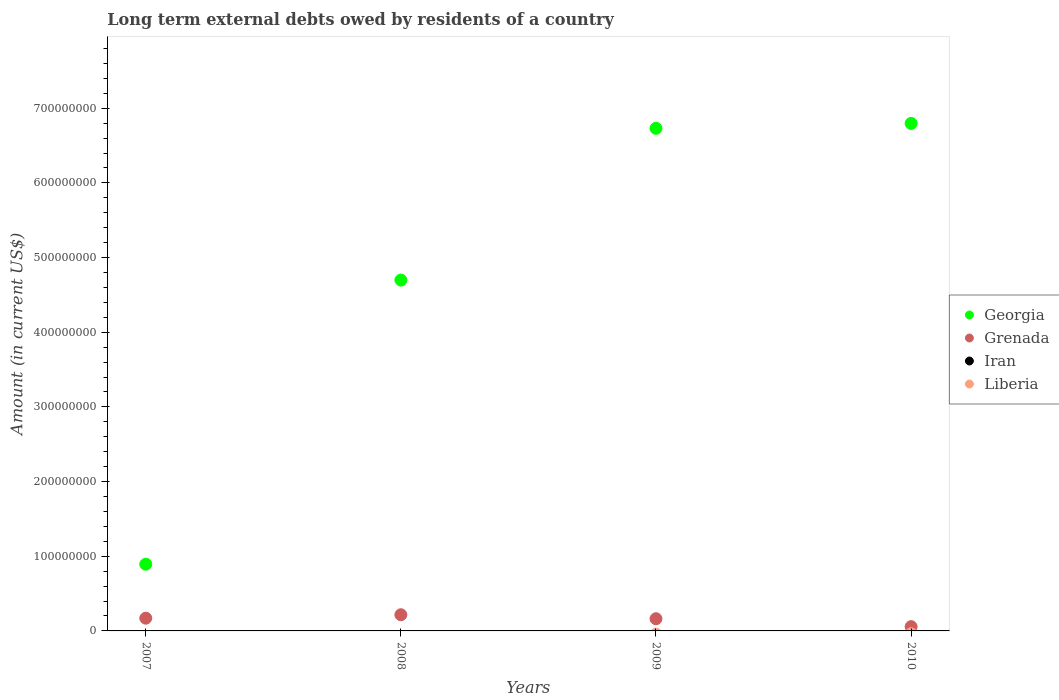How many different coloured dotlines are there?
Provide a succinct answer. 2. Is the number of dotlines equal to the number of legend labels?
Provide a succinct answer. No. What is the amount of long-term external debts owed by residents in Georgia in 2009?
Provide a short and direct response. 6.73e+08. Across all years, what is the maximum amount of long-term external debts owed by residents in Georgia?
Give a very brief answer. 6.80e+08. Across all years, what is the minimum amount of long-term external debts owed by residents in Liberia?
Offer a very short reply. 0. What is the total amount of long-term external debts owed by residents in Grenada in the graph?
Provide a short and direct response. 6.08e+07. What is the difference between the amount of long-term external debts owed by residents in Georgia in 2008 and that in 2009?
Offer a very short reply. -2.03e+08. What is the difference between the amount of long-term external debts owed by residents in Grenada in 2008 and the amount of long-term external debts owed by residents in Iran in 2009?
Your response must be concise. 2.17e+07. What is the average amount of long-term external debts owed by residents in Grenada per year?
Provide a short and direct response. 1.52e+07. In the year 2007, what is the difference between the amount of long-term external debts owed by residents in Georgia and amount of long-term external debts owed by residents in Grenada?
Keep it short and to the point. 7.23e+07. What is the ratio of the amount of long-term external debts owed by residents in Georgia in 2007 to that in 2008?
Give a very brief answer. 0.19. Is the amount of long-term external debts owed by residents in Georgia in 2007 less than that in 2008?
Offer a very short reply. Yes. Is the difference between the amount of long-term external debts owed by residents in Georgia in 2007 and 2010 greater than the difference between the amount of long-term external debts owed by residents in Grenada in 2007 and 2010?
Make the answer very short. No. What is the difference between the highest and the second highest amount of long-term external debts owed by residents in Georgia?
Provide a short and direct response. 6.56e+06. What is the difference between the highest and the lowest amount of long-term external debts owed by residents in Georgia?
Offer a terse response. 5.90e+08. In how many years, is the amount of long-term external debts owed by residents in Liberia greater than the average amount of long-term external debts owed by residents in Liberia taken over all years?
Ensure brevity in your answer.  0. Is the amount of long-term external debts owed by residents in Liberia strictly greater than the amount of long-term external debts owed by residents in Iran over the years?
Your answer should be compact. Yes. How many dotlines are there?
Provide a short and direct response. 2. How many years are there in the graph?
Give a very brief answer. 4. Are the values on the major ticks of Y-axis written in scientific E-notation?
Your answer should be compact. No. Does the graph contain grids?
Your answer should be compact. No. How are the legend labels stacked?
Provide a short and direct response. Vertical. What is the title of the graph?
Ensure brevity in your answer.  Long term external debts owed by residents of a country. What is the label or title of the X-axis?
Provide a succinct answer. Years. What is the Amount (in current US$) in Georgia in 2007?
Provide a short and direct response. 8.93e+07. What is the Amount (in current US$) in Grenada in 2007?
Offer a terse response. 1.71e+07. What is the Amount (in current US$) in Georgia in 2008?
Provide a short and direct response. 4.70e+08. What is the Amount (in current US$) in Grenada in 2008?
Offer a very short reply. 2.17e+07. What is the Amount (in current US$) of Iran in 2008?
Provide a succinct answer. 0. What is the Amount (in current US$) in Liberia in 2008?
Ensure brevity in your answer.  0. What is the Amount (in current US$) of Georgia in 2009?
Offer a very short reply. 6.73e+08. What is the Amount (in current US$) of Grenada in 2009?
Ensure brevity in your answer.  1.63e+07. What is the Amount (in current US$) of Iran in 2009?
Your answer should be very brief. 0. What is the Amount (in current US$) in Georgia in 2010?
Your answer should be very brief. 6.80e+08. What is the Amount (in current US$) in Grenada in 2010?
Provide a short and direct response. 5.72e+06. What is the Amount (in current US$) of Liberia in 2010?
Give a very brief answer. 0. Across all years, what is the maximum Amount (in current US$) of Georgia?
Keep it short and to the point. 6.80e+08. Across all years, what is the maximum Amount (in current US$) in Grenada?
Keep it short and to the point. 2.17e+07. Across all years, what is the minimum Amount (in current US$) in Georgia?
Your answer should be compact. 8.93e+07. Across all years, what is the minimum Amount (in current US$) in Grenada?
Ensure brevity in your answer.  5.72e+06. What is the total Amount (in current US$) in Georgia in the graph?
Provide a short and direct response. 1.91e+09. What is the total Amount (in current US$) of Grenada in the graph?
Offer a terse response. 6.08e+07. What is the difference between the Amount (in current US$) of Georgia in 2007 and that in 2008?
Ensure brevity in your answer.  -3.81e+08. What is the difference between the Amount (in current US$) in Grenada in 2007 and that in 2008?
Your answer should be very brief. -4.62e+06. What is the difference between the Amount (in current US$) in Georgia in 2007 and that in 2009?
Give a very brief answer. -5.84e+08. What is the difference between the Amount (in current US$) of Grenada in 2007 and that in 2009?
Provide a succinct answer. 7.29e+05. What is the difference between the Amount (in current US$) in Georgia in 2007 and that in 2010?
Provide a short and direct response. -5.90e+08. What is the difference between the Amount (in current US$) in Grenada in 2007 and that in 2010?
Give a very brief answer. 1.13e+07. What is the difference between the Amount (in current US$) of Georgia in 2008 and that in 2009?
Give a very brief answer. -2.03e+08. What is the difference between the Amount (in current US$) in Grenada in 2008 and that in 2009?
Make the answer very short. 5.35e+06. What is the difference between the Amount (in current US$) in Georgia in 2008 and that in 2010?
Keep it short and to the point. -2.10e+08. What is the difference between the Amount (in current US$) in Grenada in 2008 and that in 2010?
Ensure brevity in your answer.  1.60e+07. What is the difference between the Amount (in current US$) in Georgia in 2009 and that in 2010?
Keep it short and to the point. -6.56e+06. What is the difference between the Amount (in current US$) of Grenada in 2009 and that in 2010?
Your answer should be compact. 1.06e+07. What is the difference between the Amount (in current US$) of Georgia in 2007 and the Amount (in current US$) of Grenada in 2008?
Ensure brevity in your answer.  6.77e+07. What is the difference between the Amount (in current US$) of Georgia in 2007 and the Amount (in current US$) of Grenada in 2009?
Offer a terse response. 7.30e+07. What is the difference between the Amount (in current US$) of Georgia in 2007 and the Amount (in current US$) of Grenada in 2010?
Give a very brief answer. 8.36e+07. What is the difference between the Amount (in current US$) in Georgia in 2008 and the Amount (in current US$) in Grenada in 2009?
Make the answer very short. 4.54e+08. What is the difference between the Amount (in current US$) of Georgia in 2008 and the Amount (in current US$) of Grenada in 2010?
Your answer should be very brief. 4.64e+08. What is the difference between the Amount (in current US$) of Georgia in 2009 and the Amount (in current US$) of Grenada in 2010?
Your answer should be compact. 6.67e+08. What is the average Amount (in current US$) of Georgia per year?
Keep it short and to the point. 4.78e+08. What is the average Amount (in current US$) in Grenada per year?
Provide a short and direct response. 1.52e+07. What is the average Amount (in current US$) in Iran per year?
Provide a succinct answer. 0. What is the average Amount (in current US$) in Liberia per year?
Give a very brief answer. 0. In the year 2007, what is the difference between the Amount (in current US$) in Georgia and Amount (in current US$) in Grenada?
Offer a terse response. 7.23e+07. In the year 2008, what is the difference between the Amount (in current US$) of Georgia and Amount (in current US$) of Grenada?
Your answer should be very brief. 4.48e+08. In the year 2009, what is the difference between the Amount (in current US$) in Georgia and Amount (in current US$) in Grenada?
Make the answer very short. 6.57e+08. In the year 2010, what is the difference between the Amount (in current US$) of Georgia and Amount (in current US$) of Grenada?
Offer a very short reply. 6.74e+08. What is the ratio of the Amount (in current US$) in Georgia in 2007 to that in 2008?
Give a very brief answer. 0.19. What is the ratio of the Amount (in current US$) of Grenada in 2007 to that in 2008?
Make the answer very short. 0.79. What is the ratio of the Amount (in current US$) of Georgia in 2007 to that in 2009?
Offer a very short reply. 0.13. What is the ratio of the Amount (in current US$) of Grenada in 2007 to that in 2009?
Your answer should be compact. 1.04. What is the ratio of the Amount (in current US$) in Georgia in 2007 to that in 2010?
Offer a very short reply. 0.13. What is the ratio of the Amount (in current US$) of Grenada in 2007 to that in 2010?
Make the answer very short. 2.98. What is the ratio of the Amount (in current US$) of Georgia in 2008 to that in 2009?
Give a very brief answer. 0.7. What is the ratio of the Amount (in current US$) in Grenada in 2008 to that in 2009?
Make the answer very short. 1.33. What is the ratio of the Amount (in current US$) in Georgia in 2008 to that in 2010?
Your answer should be compact. 0.69. What is the ratio of the Amount (in current US$) of Grenada in 2008 to that in 2010?
Make the answer very short. 3.79. What is the ratio of the Amount (in current US$) in Georgia in 2009 to that in 2010?
Provide a short and direct response. 0.99. What is the ratio of the Amount (in current US$) in Grenada in 2009 to that in 2010?
Your answer should be compact. 2.86. What is the difference between the highest and the second highest Amount (in current US$) of Georgia?
Ensure brevity in your answer.  6.56e+06. What is the difference between the highest and the second highest Amount (in current US$) in Grenada?
Your response must be concise. 4.62e+06. What is the difference between the highest and the lowest Amount (in current US$) of Georgia?
Ensure brevity in your answer.  5.90e+08. What is the difference between the highest and the lowest Amount (in current US$) of Grenada?
Your answer should be very brief. 1.60e+07. 